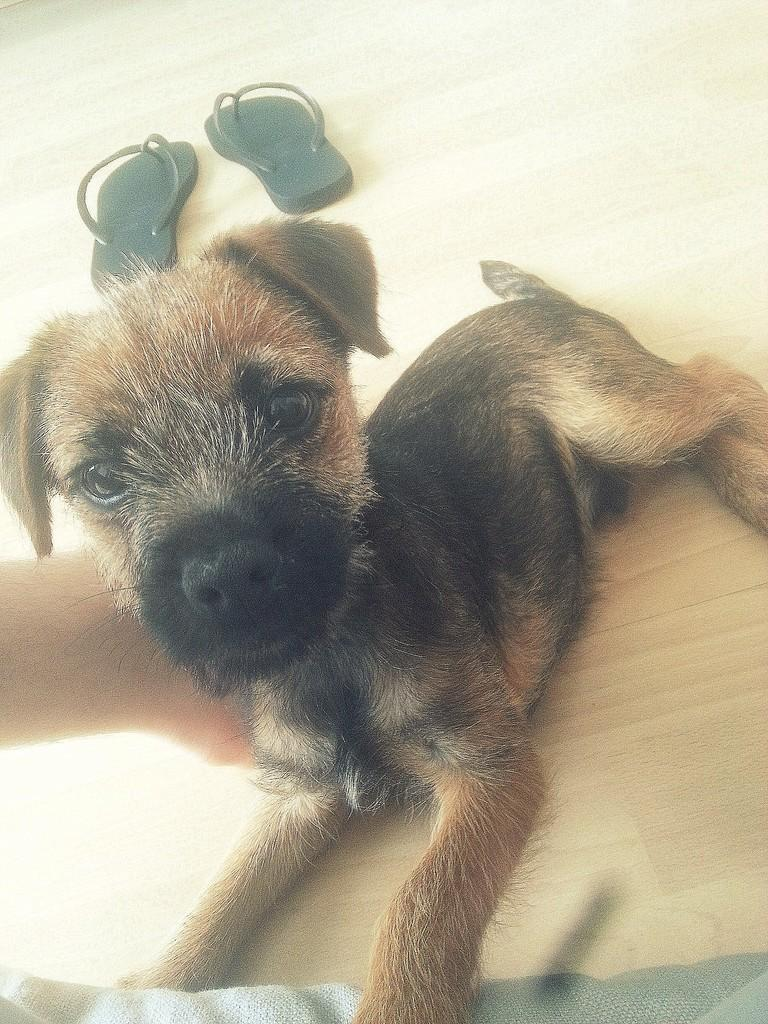What type of animal is in the image? There is a dog in the image. What type of footwear is visible in the image? There are slippers in the image. What material is the surface that the dog and slippers are on? The wooden surface is present in the image. What type of division can be seen in the image? There is no division present in the image; it is a single scene featuring a dog, slippers, and a wooden surface. 